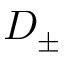Convert formula to latex. <formula><loc_0><loc_0><loc_500><loc_500>D _ { \pm }</formula> 